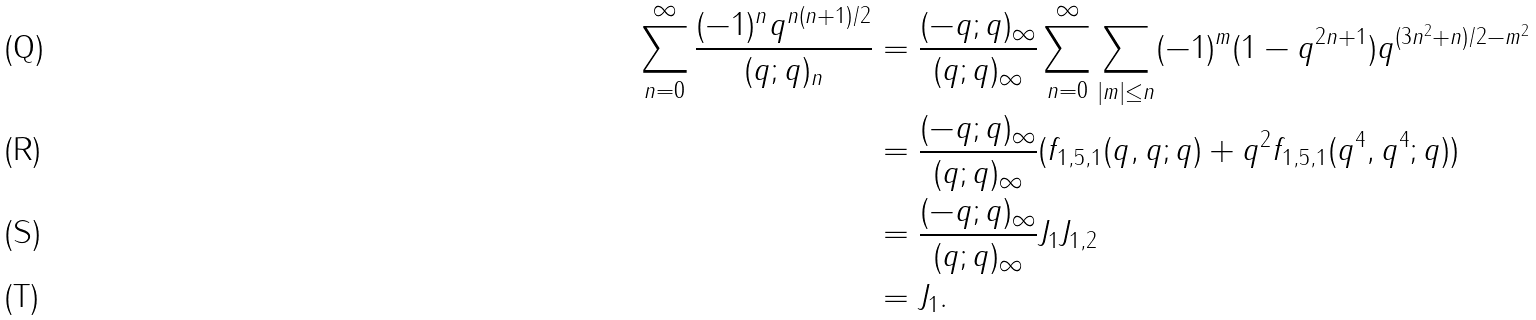<formula> <loc_0><loc_0><loc_500><loc_500>\sum _ { n = 0 } ^ { \infty } \frac { ( - 1 ) ^ { n } q ^ { n ( n + 1 ) / 2 } } { ( q ; q ) _ { n } } & = \frac { ( - q ; q ) _ { \infty } } { ( q ; q ) _ { \infty } } \sum _ { n = 0 } ^ { \infty } \sum _ { | m | \leq n } ( - 1 ) ^ { m } ( 1 - q ^ { 2 n + 1 } ) q ^ { ( 3 n ^ { 2 } + n ) / 2 - m ^ { 2 } } \\ & = \frac { ( - q ; q ) _ { \infty } } { ( q ; q ) _ { \infty } } ( f _ { 1 , 5 , 1 } ( q , q ; q ) + q ^ { 2 } f _ { 1 , 5 , 1 } ( q ^ { 4 } , q ^ { 4 } ; q ) ) \\ & = \frac { ( - q ; q ) _ { \infty } } { ( q ; q ) _ { \infty } } J _ { 1 } J _ { 1 , 2 } \\ & = J _ { 1 } .</formula> 